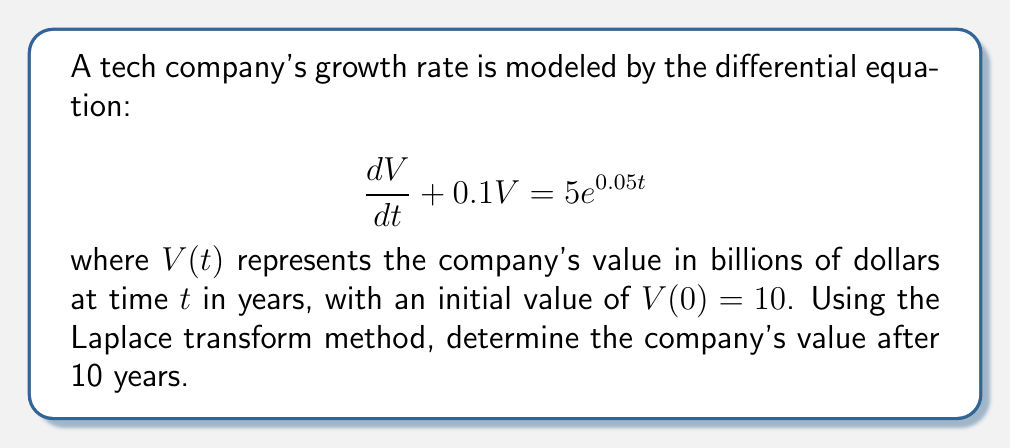Can you answer this question? 1) First, let's take the Laplace transform of both sides of the equation:
   $$\mathcal{L}\left\{\frac{dV}{dt} + 0.1V\right\} = \mathcal{L}\{5e^{0.05t}\}$$

2) Using Laplace transform properties:
   $$s\mathcal{L}\{V\} - V(0) + 0.1\mathcal{L}\{V\} = \frac{5}{s-0.05}$$

3) Substitute $V(0) = 10$ and let $\mathcal{L}\{V\} = \bar{V}(s)$:
   $$(s + 0.1)\bar{V}(s) - 10 = \frac{5}{s-0.05}$$

4) Solve for $\bar{V}(s)$:
   $$\bar{V}(s) = \frac{10}{s + 0.1} + \frac{5}{(s + 0.1)(s - 0.05)}$$

5) Decompose into partial fractions:
   $$\bar{V}(s) = \frac{10}{s + 0.1} + \frac{A}{s + 0.1} + \frac{B}{s - 0.05}$$
   
   where $A = -\frac{100}{3}$ and $B = \frac{100}{3}$

6) Take the inverse Laplace transform:
   $$V(t) = 10e^{-0.1t} - \frac{100}{3}e^{-0.1t} + \frac{100}{3}e^{0.05t}$$

7) Simplify:
   $$V(t) = -\frac{20}{3}e^{-0.1t} + \frac{100}{3}e^{0.05t}$$

8) Evaluate at $t = 10$:
   $$V(10) = -\frac{20}{3}e^{-1} + \frac{100}{3}e^{0.5} \approx 61.97$$
Answer: $61.97 billion 